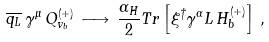Convert formula to latex. <formula><loc_0><loc_0><loc_500><loc_500>\overline { q _ { L } } \, \gamma ^ { \mu } \, Q _ { v _ { b } } ^ { ( + ) } \, \longrightarrow \, \frac { \alpha _ { H } } { 2 } T r \left [ \xi ^ { \dagger } \gamma ^ { \alpha } L \, H _ { b } ^ { ( + ) } \right ] \, ,</formula> 